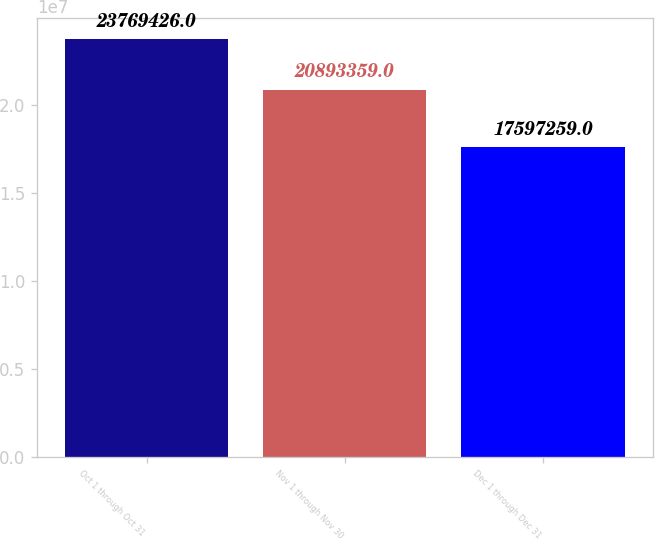<chart> <loc_0><loc_0><loc_500><loc_500><bar_chart><fcel>Oct 1 through Oct 31<fcel>Nov 1 through Nov 30<fcel>Dec 1 through Dec 31<nl><fcel>2.37694e+07<fcel>2.08934e+07<fcel>1.75973e+07<nl></chart> 